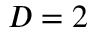<formula> <loc_0><loc_0><loc_500><loc_500>D = 2</formula> 